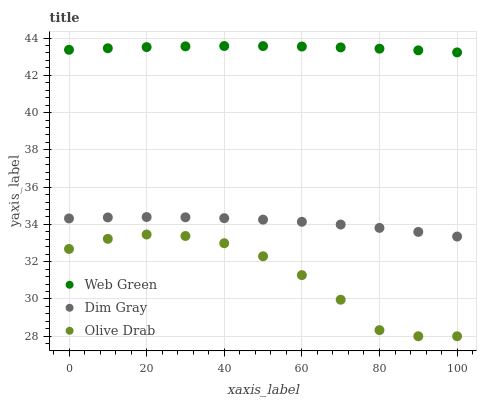Does Olive Drab have the minimum area under the curve?
Answer yes or no. Yes. Does Web Green have the maximum area under the curve?
Answer yes or no. Yes. Does Web Green have the minimum area under the curve?
Answer yes or no. No. Does Olive Drab have the maximum area under the curve?
Answer yes or no. No. Is Web Green the smoothest?
Answer yes or no. Yes. Is Olive Drab the roughest?
Answer yes or no. Yes. Is Olive Drab the smoothest?
Answer yes or no. No. Is Web Green the roughest?
Answer yes or no. No. Does Olive Drab have the lowest value?
Answer yes or no. Yes. Does Web Green have the lowest value?
Answer yes or no. No. Does Web Green have the highest value?
Answer yes or no. Yes. Does Olive Drab have the highest value?
Answer yes or no. No. Is Olive Drab less than Dim Gray?
Answer yes or no. Yes. Is Dim Gray greater than Olive Drab?
Answer yes or no. Yes. Does Olive Drab intersect Dim Gray?
Answer yes or no. No. 